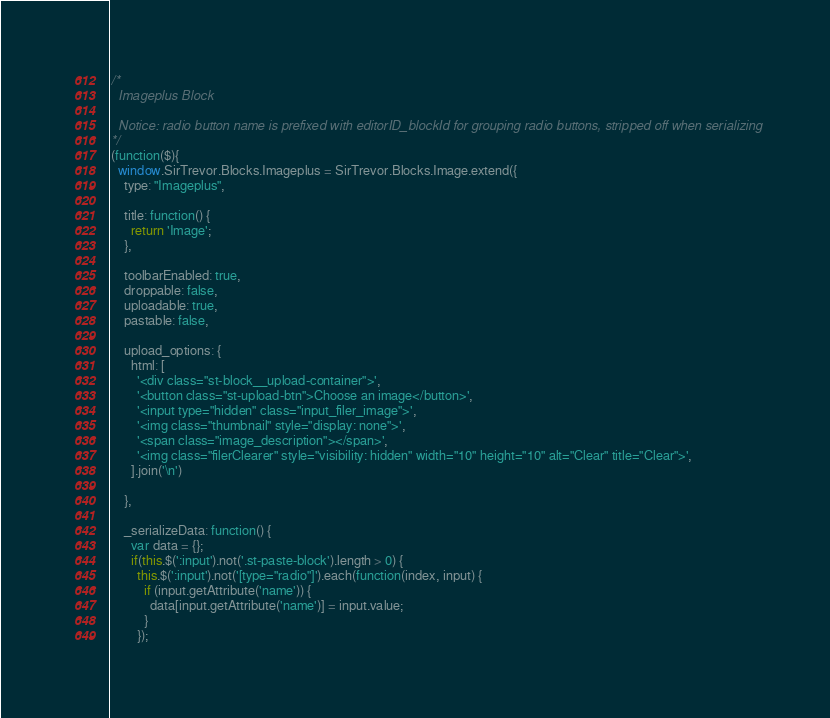<code> <loc_0><loc_0><loc_500><loc_500><_JavaScript_>/*
  Imageplus Block

  Notice: radio button name is prefixed with editorID_blockId for grouping radio buttons, stripped off when serializing
*/
(function($){
  window.SirTrevor.Blocks.Imageplus = SirTrevor.Blocks.Image.extend({
    type: "Imageplus",

    title: function() {
      return 'Image';
    },

    toolbarEnabled: true,
    droppable: false,
    uploadable: true,
    pastable: false,

    upload_options: {
      html: [
        '<div class="st-block__upload-container">',
        '<button class="st-upload-btn">Choose an image</button>',
        '<input type="hidden" class="input_filer_image">',
        '<img class="thumbnail" style="display: none">',
        '<span class="image_description"></span>',
        '<img class="filerClearer" style="visibility: hidden" width="10" height="10" alt="Clear" title="Clear">',
      ].join('\n')

    },

    _serializeData: function() {
      var data = {};
      if(this.$(':input').not('.st-paste-block').length > 0) {
        this.$(':input').not('[type="radio"]').each(function(index, input) {
          if (input.getAttribute('name')) {
            data[input.getAttribute('name')] = input.value;
          }
        });</code> 